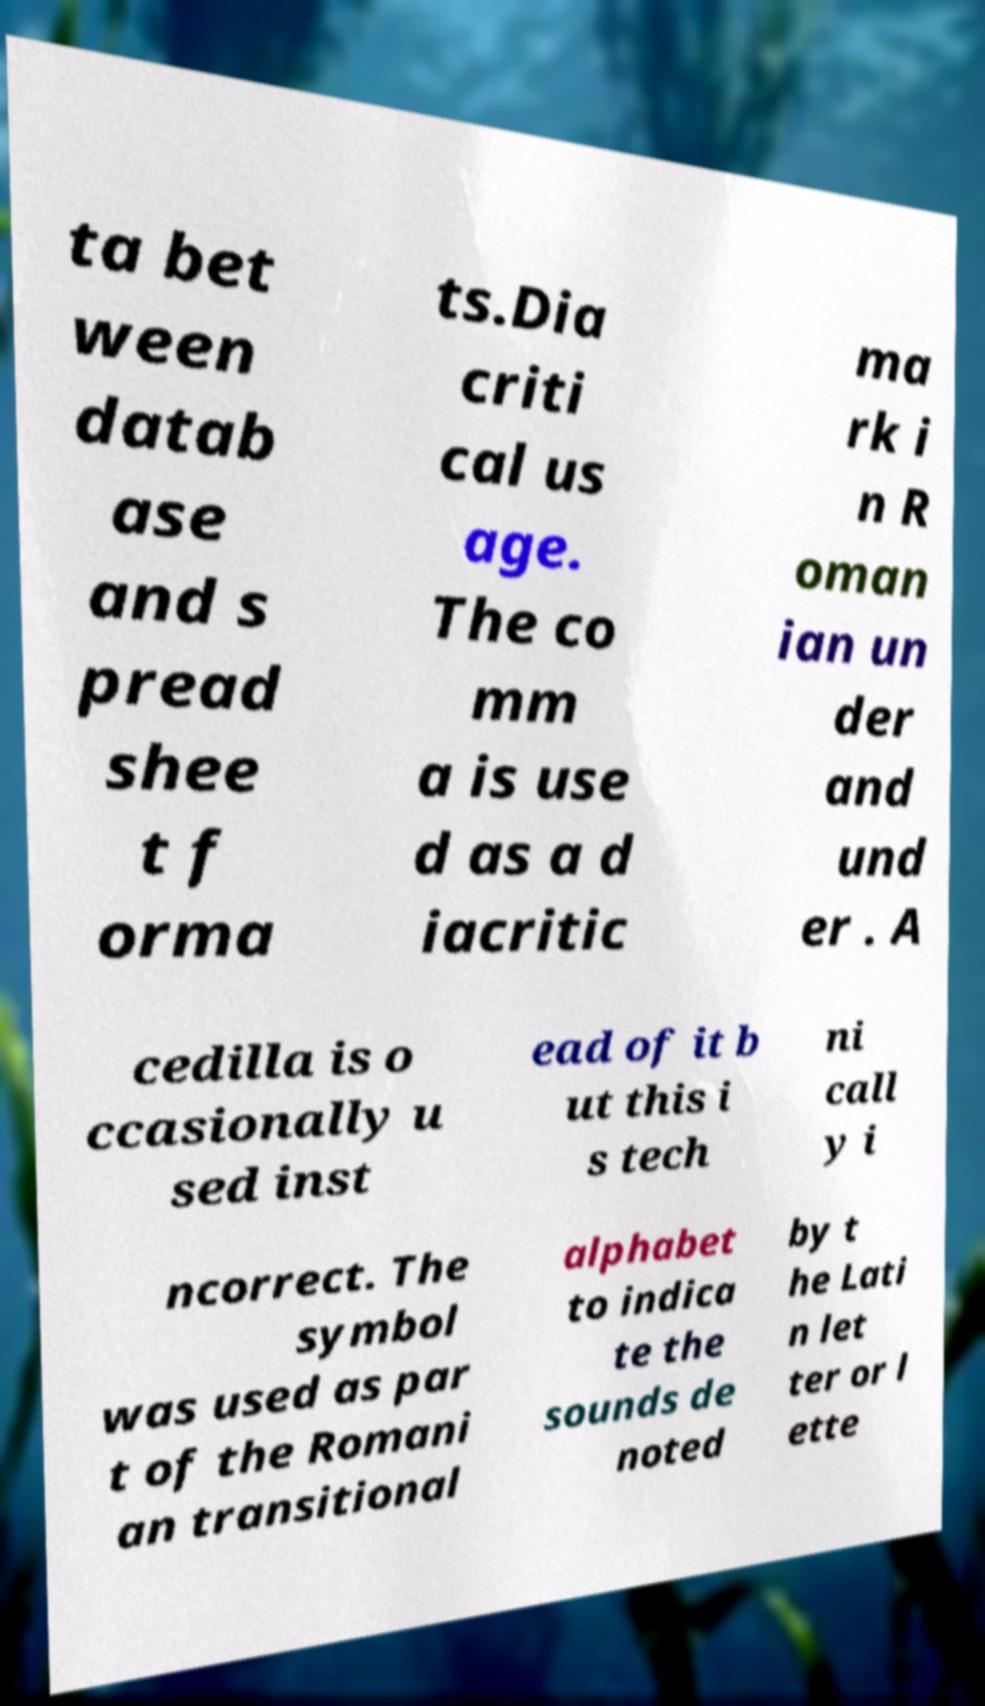What messages or text are displayed in this image? I need them in a readable, typed format. ta bet ween datab ase and s pread shee t f orma ts.Dia criti cal us age. The co mm a is use d as a d iacritic ma rk i n R oman ian un der and und er . A cedilla is o ccasionally u sed inst ead of it b ut this i s tech ni call y i ncorrect. The symbol was used as par t of the Romani an transitional alphabet to indica te the sounds de noted by t he Lati n let ter or l ette 